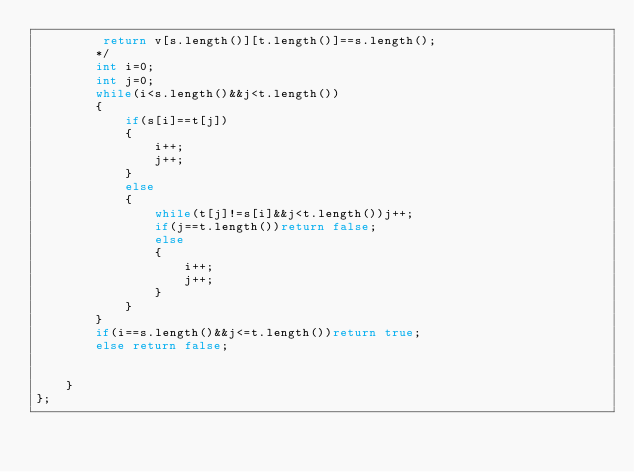Convert code to text. <code><loc_0><loc_0><loc_500><loc_500><_C++_>         return v[s.length()][t.length()]==s.length();
        */
        int i=0;
        int j=0;
        while(i<s.length()&&j<t.length())
        {
            if(s[i]==t[j])
            {
                i++;
                j++;
            }
            else 
            {
                while(t[j]!=s[i]&&j<t.length())j++;
                if(j==t.length())return false;
                else 
                {
                    i++;
                    j++;
                }
            }
        }
        if(i==s.length()&&j<=t.length())return true;
        else return false;
       
        
    }
};
</code> 